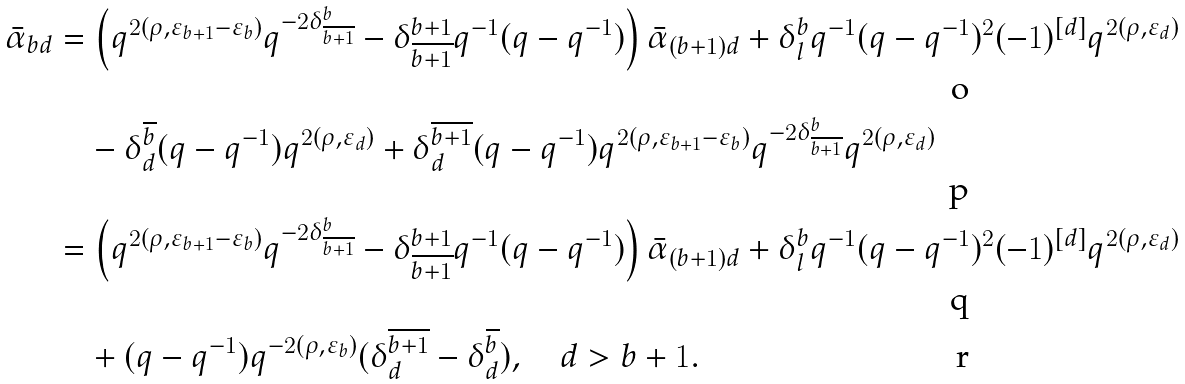Convert formula to latex. <formula><loc_0><loc_0><loc_500><loc_500>\bar { \alpha } _ { b d } & = \left ( q ^ { 2 ( \rho , \varepsilon _ { b + 1 } - \varepsilon _ { b } ) } q ^ { - 2 \delta ^ { b } _ { \overline { b + 1 } } } - \delta ^ { b + 1 } _ { \overline { b + 1 } } q ^ { - 1 } ( q - q ^ { - 1 } ) \right ) \bar { \alpha } _ { ( b + 1 ) d } + \delta ^ { b } _ { l } q ^ { - 1 } ( q - q ^ { - 1 } ) ^ { 2 } ( - 1 ) ^ { [ d ] } q ^ { 2 ( \rho , \varepsilon _ { d } ) } \\ & \quad - \delta ^ { \overline { b } } _ { d } ( q - q ^ { - 1 } ) q ^ { 2 ( \rho , \varepsilon _ { d } ) } + \delta ^ { \overline { b + 1 } } _ { d } ( q - q ^ { - 1 } ) q ^ { 2 ( \rho , \varepsilon _ { b + 1 } - \varepsilon _ { b } ) } q ^ { - 2 \delta ^ { b } _ { \overline { b + 1 } } } q ^ { 2 ( \rho , \varepsilon _ { d } ) } \\ & = \left ( q ^ { 2 ( \rho , \varepsilon _ { b + 1 } - \varepsilon _ { b } ) } q ^ { - 2 \delta ^ { b } _ { \overline { b + 1 } } } - \delta ^ { b + 1 } _ { \overline { b + 1 } } q ^ { - 1 } ( q - q ^ { - 1 } ) \right ) \bar { \alpha } _ { ( b + 1 ) d } + \delta ^ { b } _ { l } q ^ { - 1 } ( q - q ^ { - 1 } ) ^ { 2 } ( - 1 ) ^ { [ d ] } q ^ { 2 ( \rho , \varepsilon _ { d } ) } \\ & \quad + ( q - q ^ { - 1 } ) q ^ { - 2 ( \rho , \varepsilon _ { b } ) } ( \delta ^ { \overline { b + 1 } } _ { d } - \delta ^ { \overline { b } } _ { d } ) , \quad d > b + 1 .</formula> 